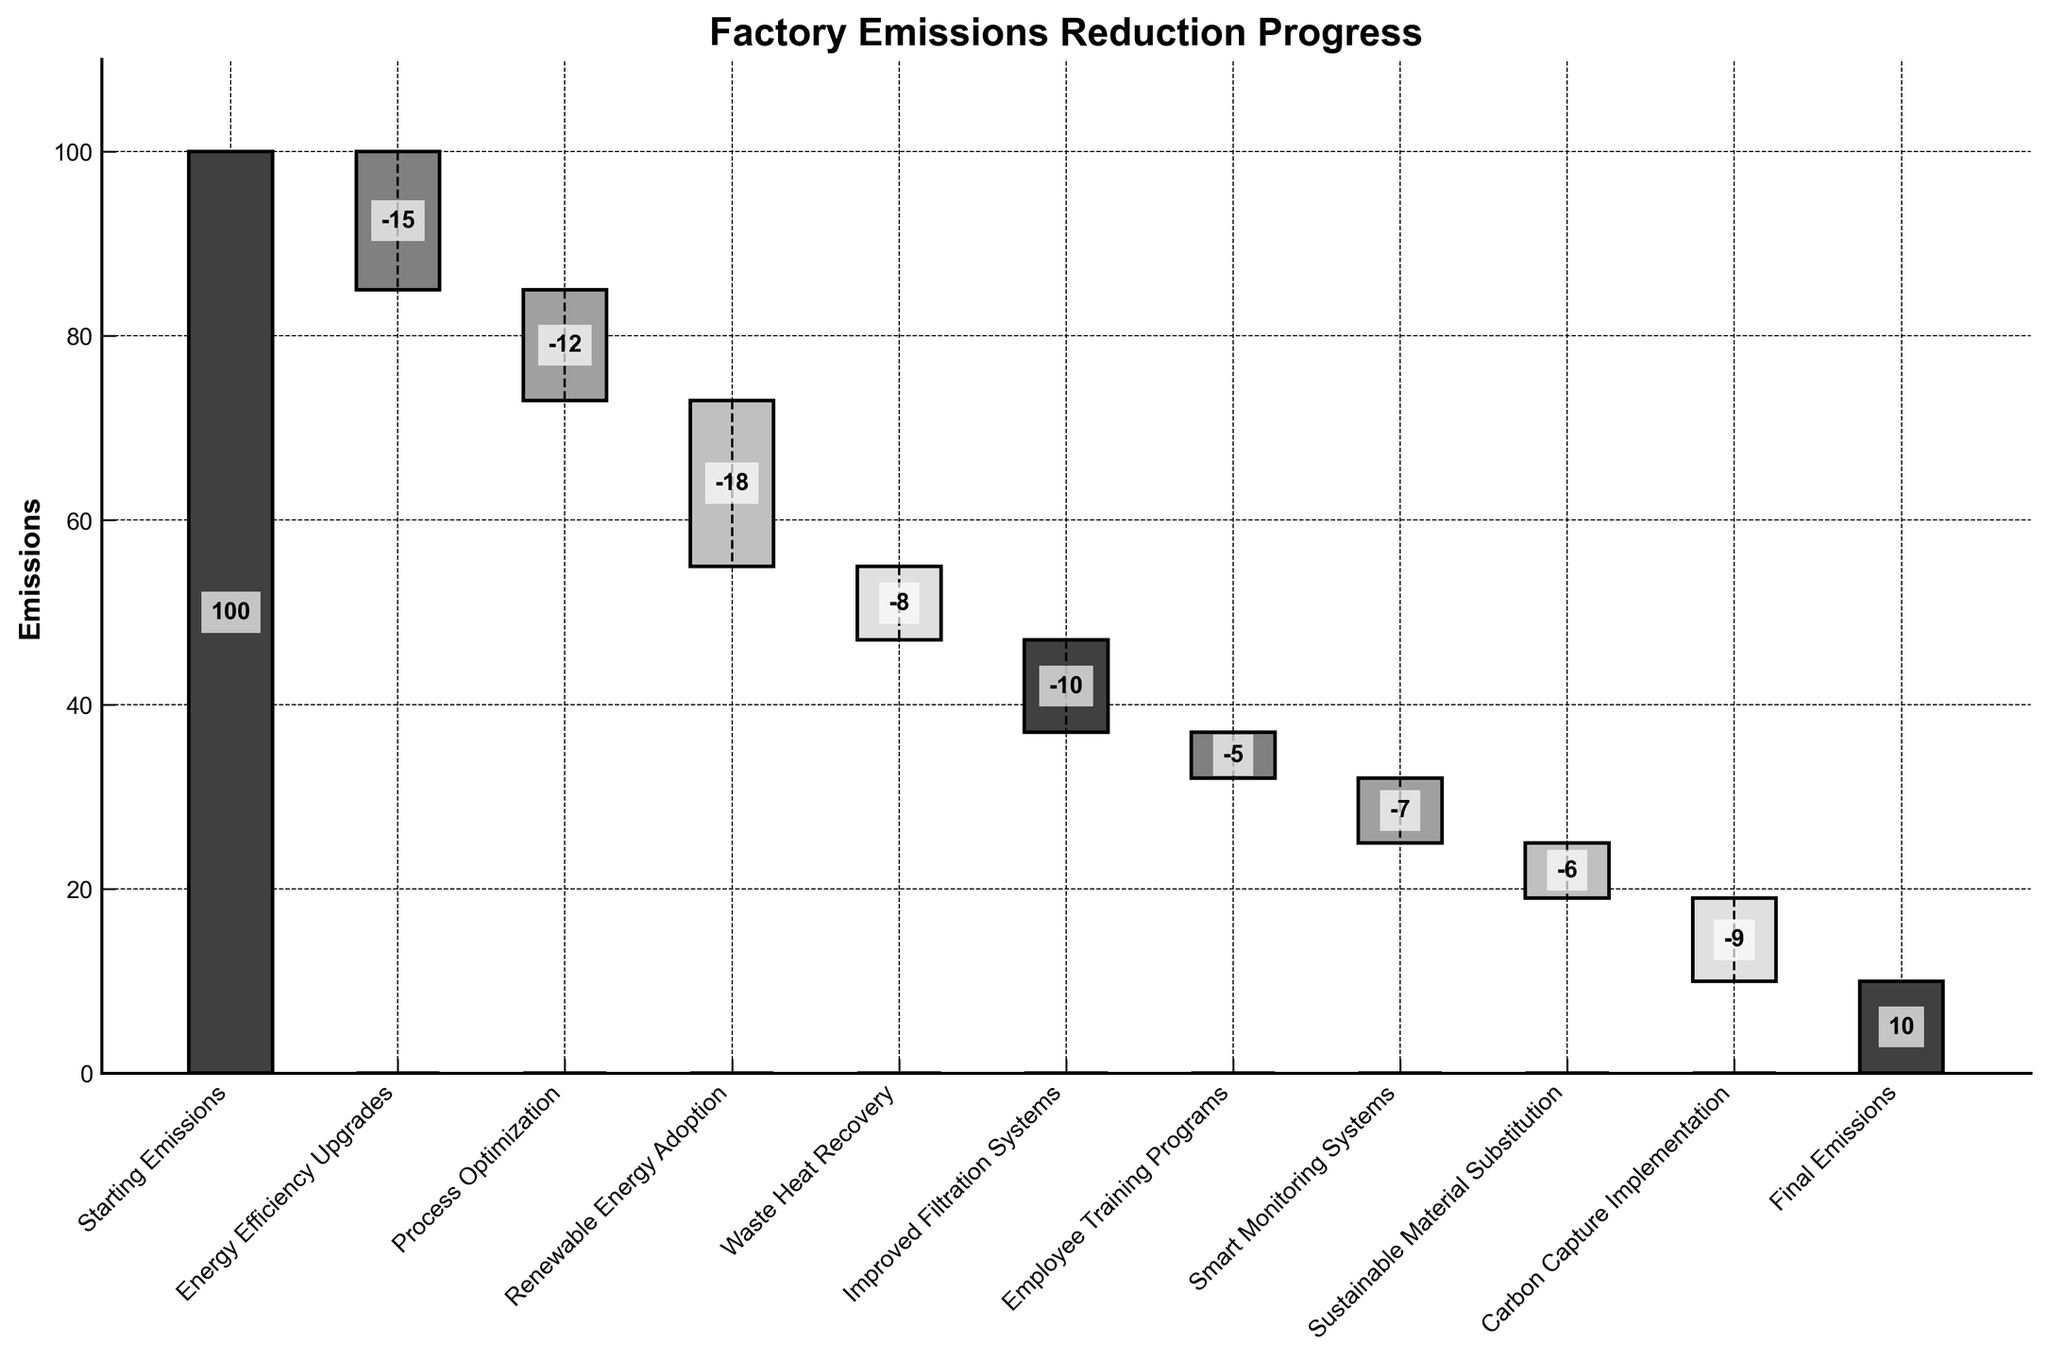What is the initial value of the factory emissions? The initial value is labeled as "Starting Emissions" on the leftmost bar of the chart, which is set to 100.
Answer: 100 How many categories are there in the chart, including the starting and final emissions? The categories can be counted by considering all the labels on the x-axis, which include "Starting Emissions", several mitigation strategies, and "Final Emissions". In total, there are 11 categories.
Answer: 11 Which mitigation strategy contributed the most to the reduction of emissions? By looking at the bars going downward from the starting emissions, "Renewable Energy Adoption" shows the largest drop, which is -18.
Answer: Renewable Energy Adoption What is the final emissions value after all mitigation strategies are applied? Refer to the "Final Emissions" bar on the far right side of the chart, which shows the final reduction amount, leading to the value of 10.
Answer: 10 What is the combined decrease in emissions from "Process Optimization" and "Improved Filtration Systems"? The emissions reduction from "Process Optimization" is -12 and from "Improved Filtration Systems" is -10. Summing these gives -12 + -10 = -22.
Answer: -22 Compare the reductions from "Energy Efficiency Upgrades" and "Sustainable Material Substitution." Which one has a greater impact? "Energy Efficiency Upgrades" has a value of -15, while "Sustainable Material Substitution" has a value of -6. Thus, "Energy Efficiency Upgrades" contributes more to the reduction.
Answer: Energy Efficiency Upgrades What is the cumulative emissions after applying "Waste Heat Recovery"? Starting from 100 and applying sequential reductions up to "Waste Heat Recovery", we compute 100 - 15 (Energy Efficiency Upgrades) - 12 (Process Optimization) - 18 (Renewable Energy Adoption) - 8 (Waste Heat Recovery), leading to a cumulative value of 47.
Answer: 47 Between "Employee Training Programs" and "Smart Monitoring Systems", which strategy shows a larger reduction in emissions? "Employee Training Programs" shows a reduction of -5, while "Smart Monitoring Systems" shows a reduction of -7. Therefore, "Smart Monitoring Systems" has a larger reduction.
Answer: Smart Monitoring Systems Calculate the total reduction in emissions from all mitigation strategies combined. Add up all the reduction values: -15 (Energy Efficiency Upgrades) - 12 (Process Optimization) - 18 (Renewable Energy Adoption) - 8 (Waste Heat Recovery) - 10 (Improved Filtration Systems) - 5 (Employee Training Programs) - 7 (Smart Monitoring Systems) - 6 (Sustainable Material Substitution) - 9 (Carbon Capture Implementation) = -90.
Answer: -90 